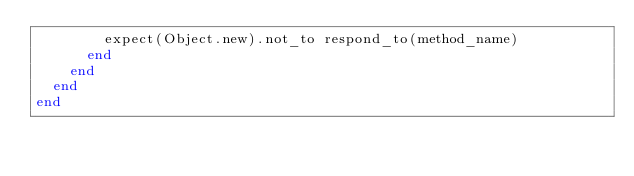<code> <loc_0><loc_0><loc_500><loc_500><_Ruby_>        expect(Object.new).not_to respond_to(method_name)
      end
    end
  end
end

</code> 